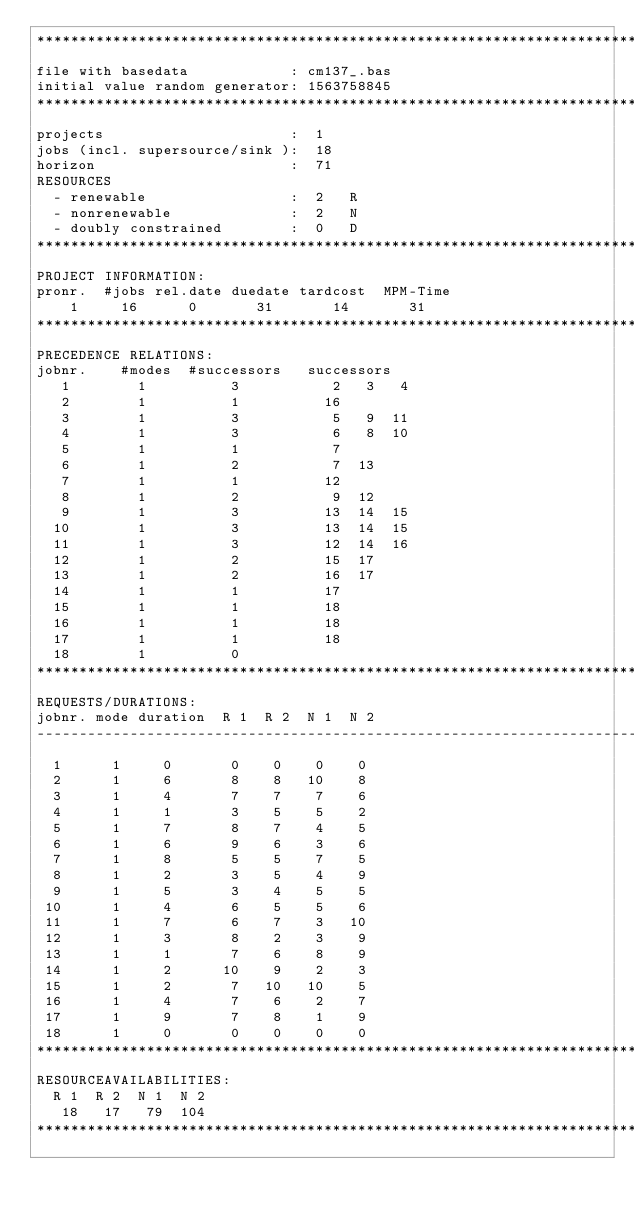Convert code to text. <code><loc_0><loc_0><loc_500><loc_500><_ObjectiveC_>************************************************************************
file with basedata            : cm137_.bas
initial value random generator: 1563758845
************************************************************************
projects                      :  1
jobs (incl. supersource/sink ):  18
horizon                       :  71
RESOURCES
  - renewable                 :  2   R
  - nonrenewable              :  2   N
  - doubly constrained        :  0   D
************************************************************************
PROJECT INFORMATION:
pronr.  #jobs rel.date duedate tardcost  MPM-Time
    1     16      0       31       14       31
************************************************************************
PRECEDENCE RELATIONS:
jobnr.    #modes  #successors   successors
   1        1          3           2   3   4
   2        1          1          16
   3        1          3           5   9  11
   4        1          3           6   8  10
   5        1          1           7
   6        1          2           7  13
   7        1          1          12
   8        1          2           9  12
   9        1          3          13  14  15
  10        1          3          13  14  15
  11        1          3          12  14  16
  12        1          2          15  17
  13        1          2          16  17
  14        1          1          17
  15        1          1          18
  16        1          1          18
  17        1          1          18
  18        1          0        
************************************************************************
REQUESTS/DURATIONS:
jobnr. mode duration  R 1  R 2  N 1  N 2
------------------------------------------------------------------------
  1      1     0       0    0    0    0
  2      1     6       8    8   10    8
  3      1     4       7    7    7    6
  4      1     1       3    5    5    2
  5      1     7       8    7    4    5
  6      1     6       9    6    3    6
  7      1     8       5    5    7    5
  8      1     2       3    5    4    9
  9      1     5       3    4    5    5
 10      1     4       6    5    5    6
 11      1     7       6    7    3   10
 12      1     3       8    2    3    9
 13      1     1       7    6    8    9
 14      1     2      10    9    2    3
 15      1     2       7   10   10    5
 16      1     4       7    6    2    7
 17      1     9       7    8    1    9
 18      1     0       0    0    0    0
************************************************************************
RESOURCEAVAILABILITIES:
  R 1  R 2  N 1  N 2
   18   17   79  104
************************************************************************
</code> 